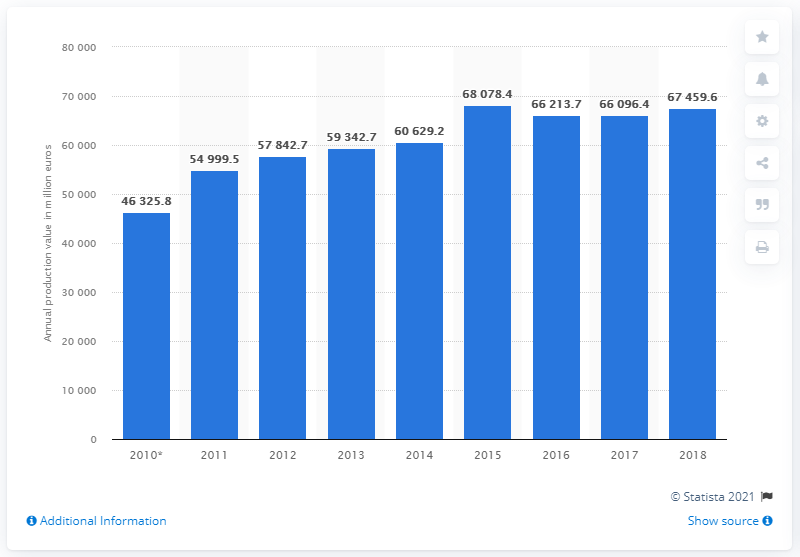Give some essential details in this illustration. In 2018, the annual production value of the construction industry in Switzerland was 67,459.6 million Swiss francs. In 2016, the production value of the construction industry in Switzerland was 66096.4. In 2018, the turnover of the Swiss construction industry was 660,964.4. 